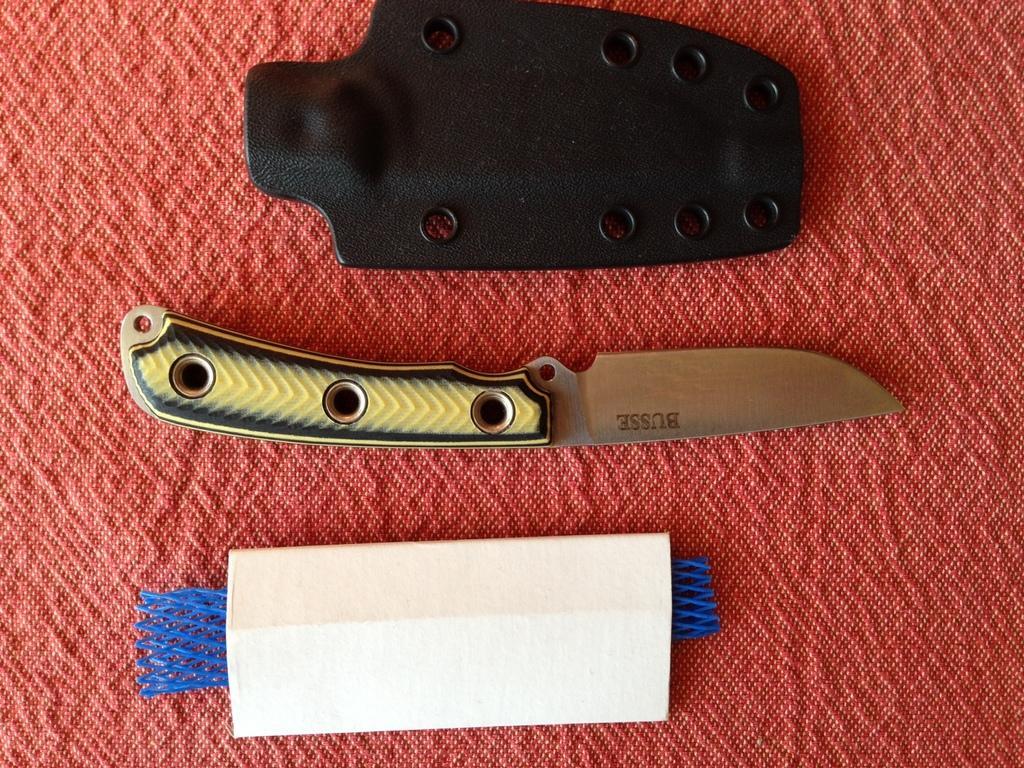In one or two sentences, can you explain what this image depicts? In this image there is a knife , a cardboard box , in another object placed in a table. 